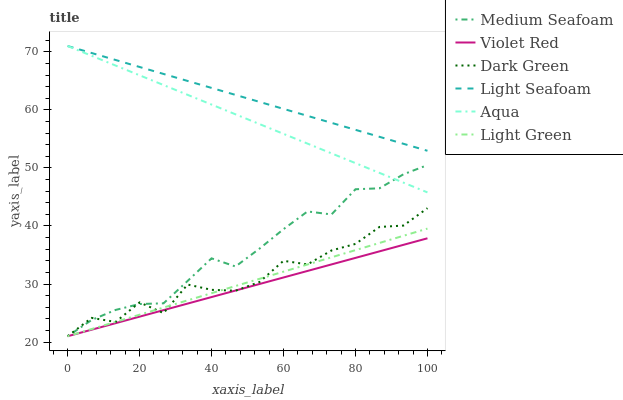Does Violet Red have the minimum area under the curve?
Answer yes or no. Yes. Does Light Seafoam have the maximum area under the curve?
Answer yes or no. Yes. Does Aqua have the minimum area under the curve?
Answer yes or no. No. Does Aqua have the maximum area under the curve?
Answer yes or no. No. Is Light Green the smoothest?
Answer yes or no. Yes. Is Dark Green the roughest?
Answer yes or no. Yes. Is Aqua the smoothest?
Answer yes or no. No. Is Aqua the roughest?
Answer yes or no. No. Does Violet Red have the lowest value?
Answer yes or no. Yes. Does Aqua have the lowest value?
Answer yes or no. No. Does Light Seafoam have the highest value?
Answer yes or no. Yes. Does Light Green have the highest value?
Answer yes or no. No. Is Violet Red less than Aqua?
Answer yes or no. Yes. Is Light Seafoam greater than Dark Green?
Answer yes or no. Yes. Does Dark Green intersect Medium Seafoam?
Answer yes or no. Yes. Is Dark Green less than Medium Seafoam?
Answer yes or no. No. Is Dark Green greater than Medium Seafoam?
Answer yes or no. No. Does Violet Red intersect Aqua?
Answer yes or no. No. 